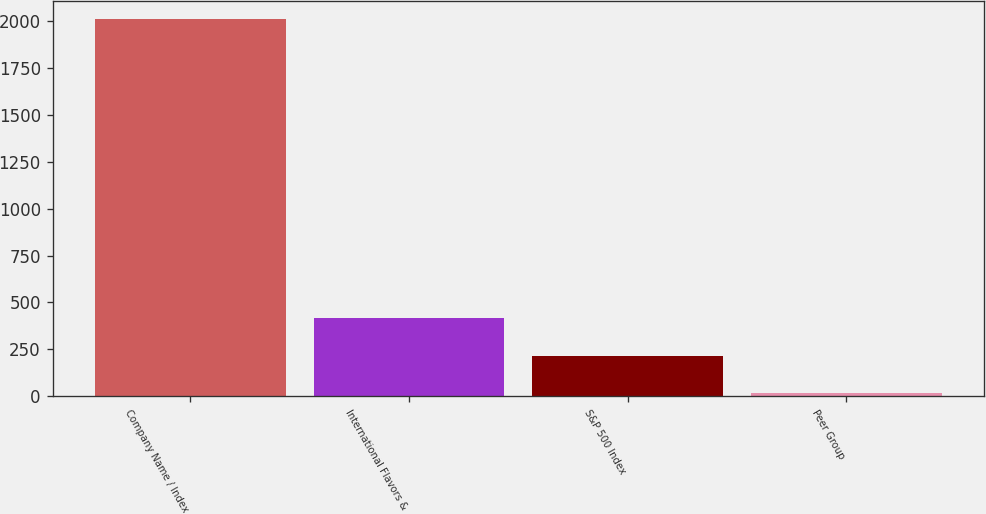Convert chart to OTSL. <chart><loc_0><loc_0><loc_500><loc_500><bar_chart><fcel>Company Name / Index<fcel>International Flavors &<fcel>S&P 500 Index<fcel>Peer Group<nl><fcel>2009<fcel>416.25<fcel>217.15<fcel>18.05<nl></chart> 